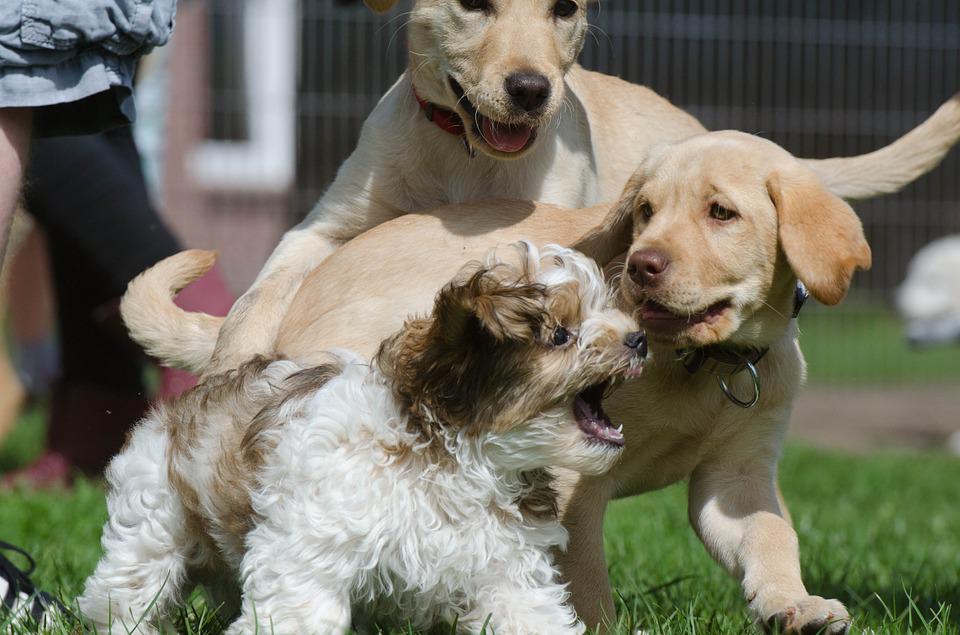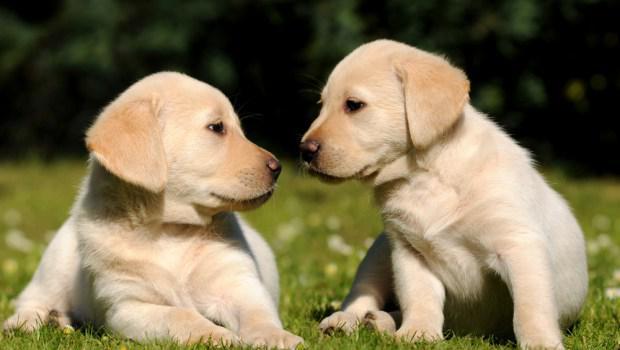The first image is the image on the left, the second image is the image on the right. Analyze the images presented: Is the assertion "In one of the images there are exactly two golden labs interacting with each other." valid? Answer yes or no. Yes. The first image is the image on the left, the second image is the image on the right. Examine the images to the left and right. Is the description "One image features exactly two dogs relaxing on the grass." accurate? Answer yes or no. Yes. 